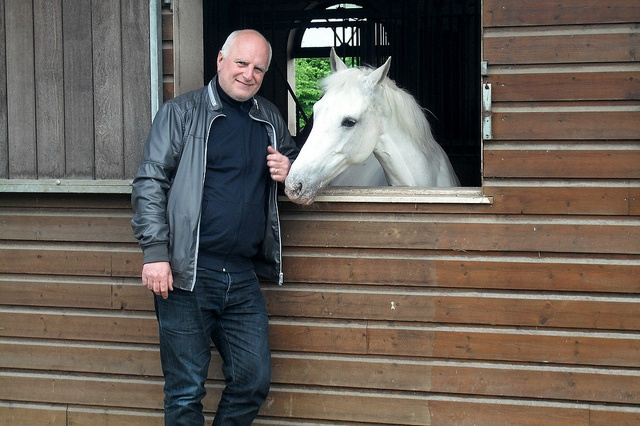Describe the objects in this image and their specific colors. I can see people in gray, black, navy, and blue tones and horse in gray, lightgray, and darkgray tones in this image. 